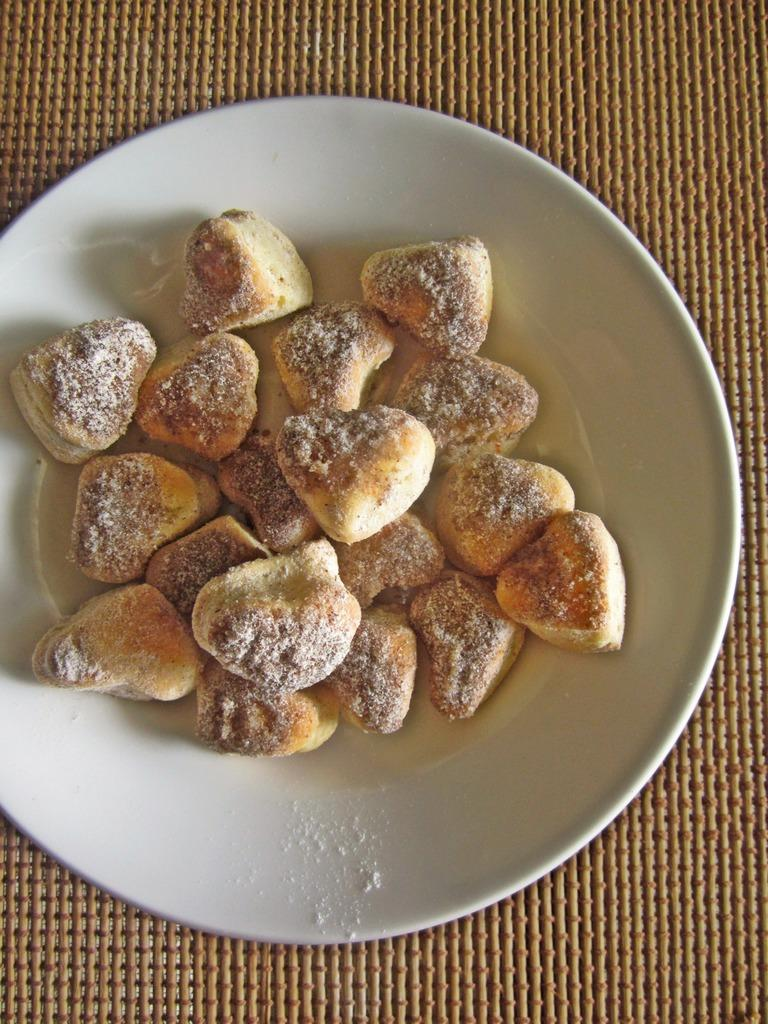What is on the surface in the image? There is a white plate in the image. What is the plate placed on? The plate is on a mat. What is on top of the plate? There are snacks on the plate. What type of dress is being worn by the snacks on the plate? There is no dress present in the image, as the snacks are not depicted as wearing clothing. 